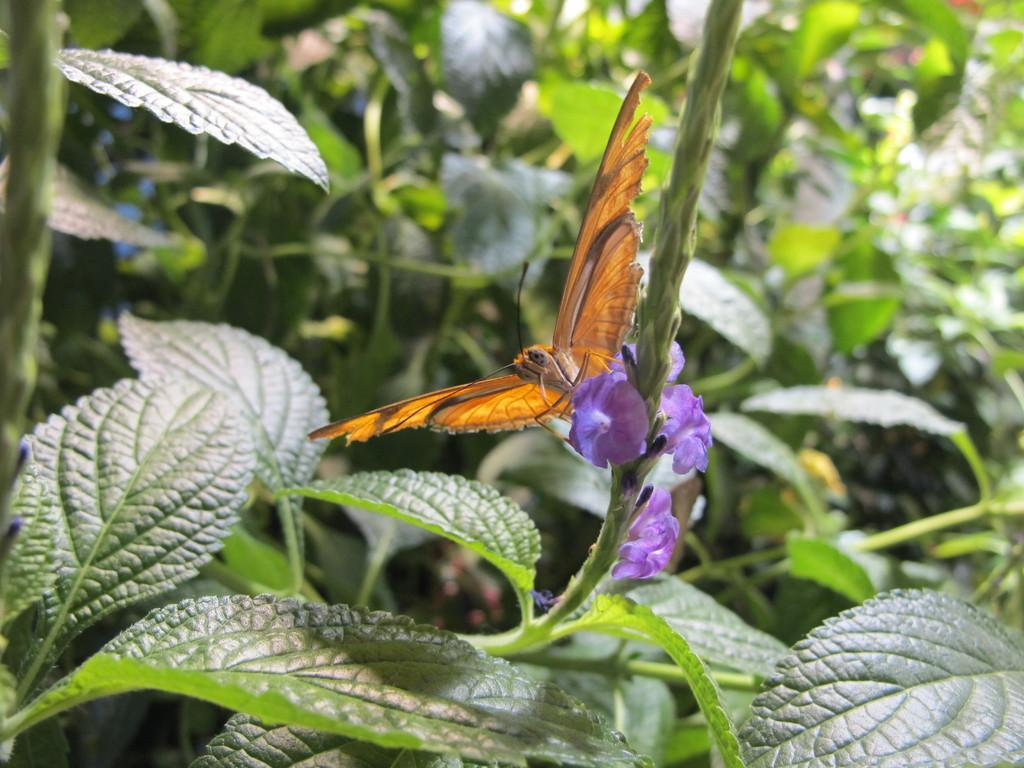What is the main subject of the image? The main subject of the image is the many plants. Are there any animals present in the image? Yes, there is a butterfly in the image. Can you describe the butterfly's physical features? The butterfly has wings and an antenna. What color are the flowers in the image? The flowers in the image are purple. What idea does the cloth represent in the image? There is no cloth present in the image, so it cannot represent any idea. 